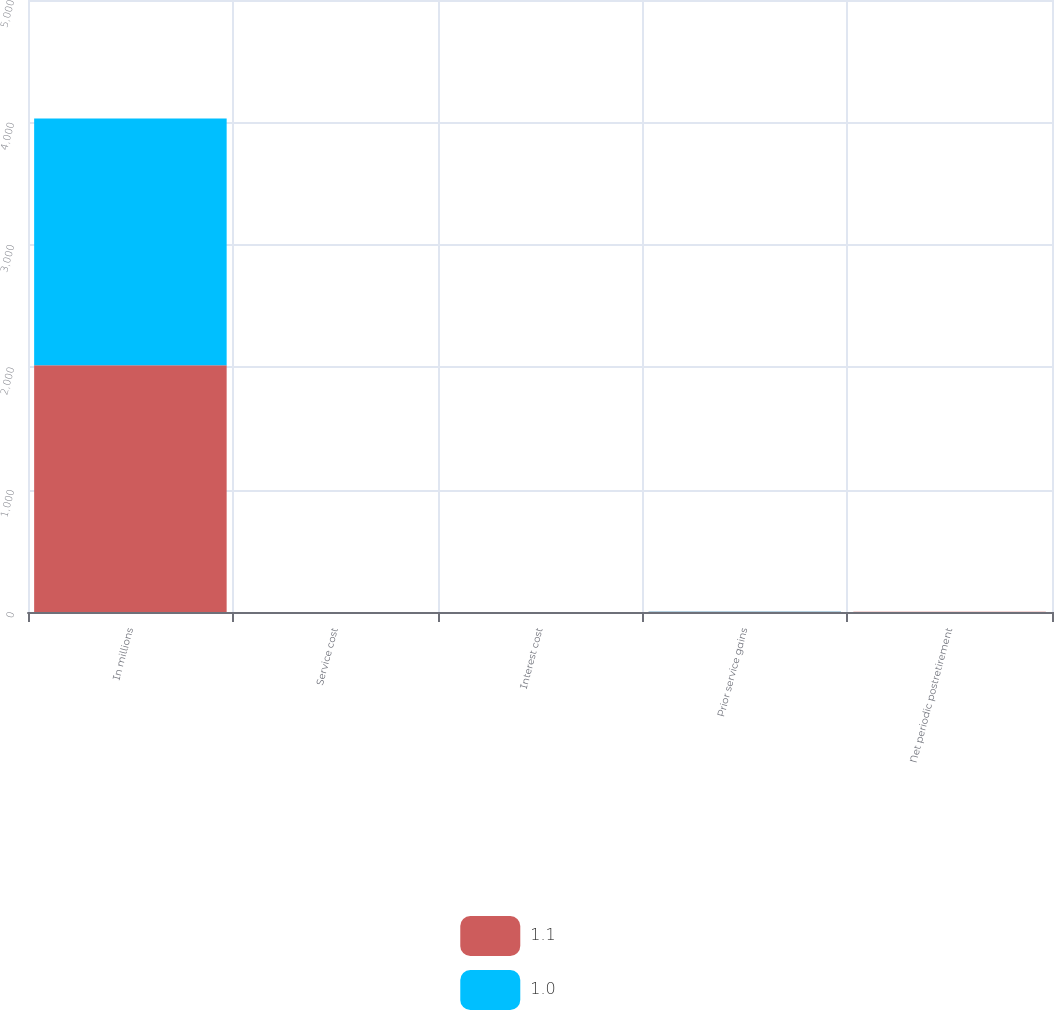Convert chart. <chart><loc_0><loc_0><loc_500><loc_500><stacked_bar_chart><ecel><fcel>In millions<fcel>Service cost<fcel>Interest cost<fcel>Prior service gains<fcel>Net periodic postretirement<nl><fcel>1.1<fcel>2016<fcel>0.1<fcel>0.4<fcel>1.6<fcel>1.1<nl><fcel>1<fcel>2015<fcel>0.1<fcel>0.5<fcel>1.6<fcel>1<nl></chart> 